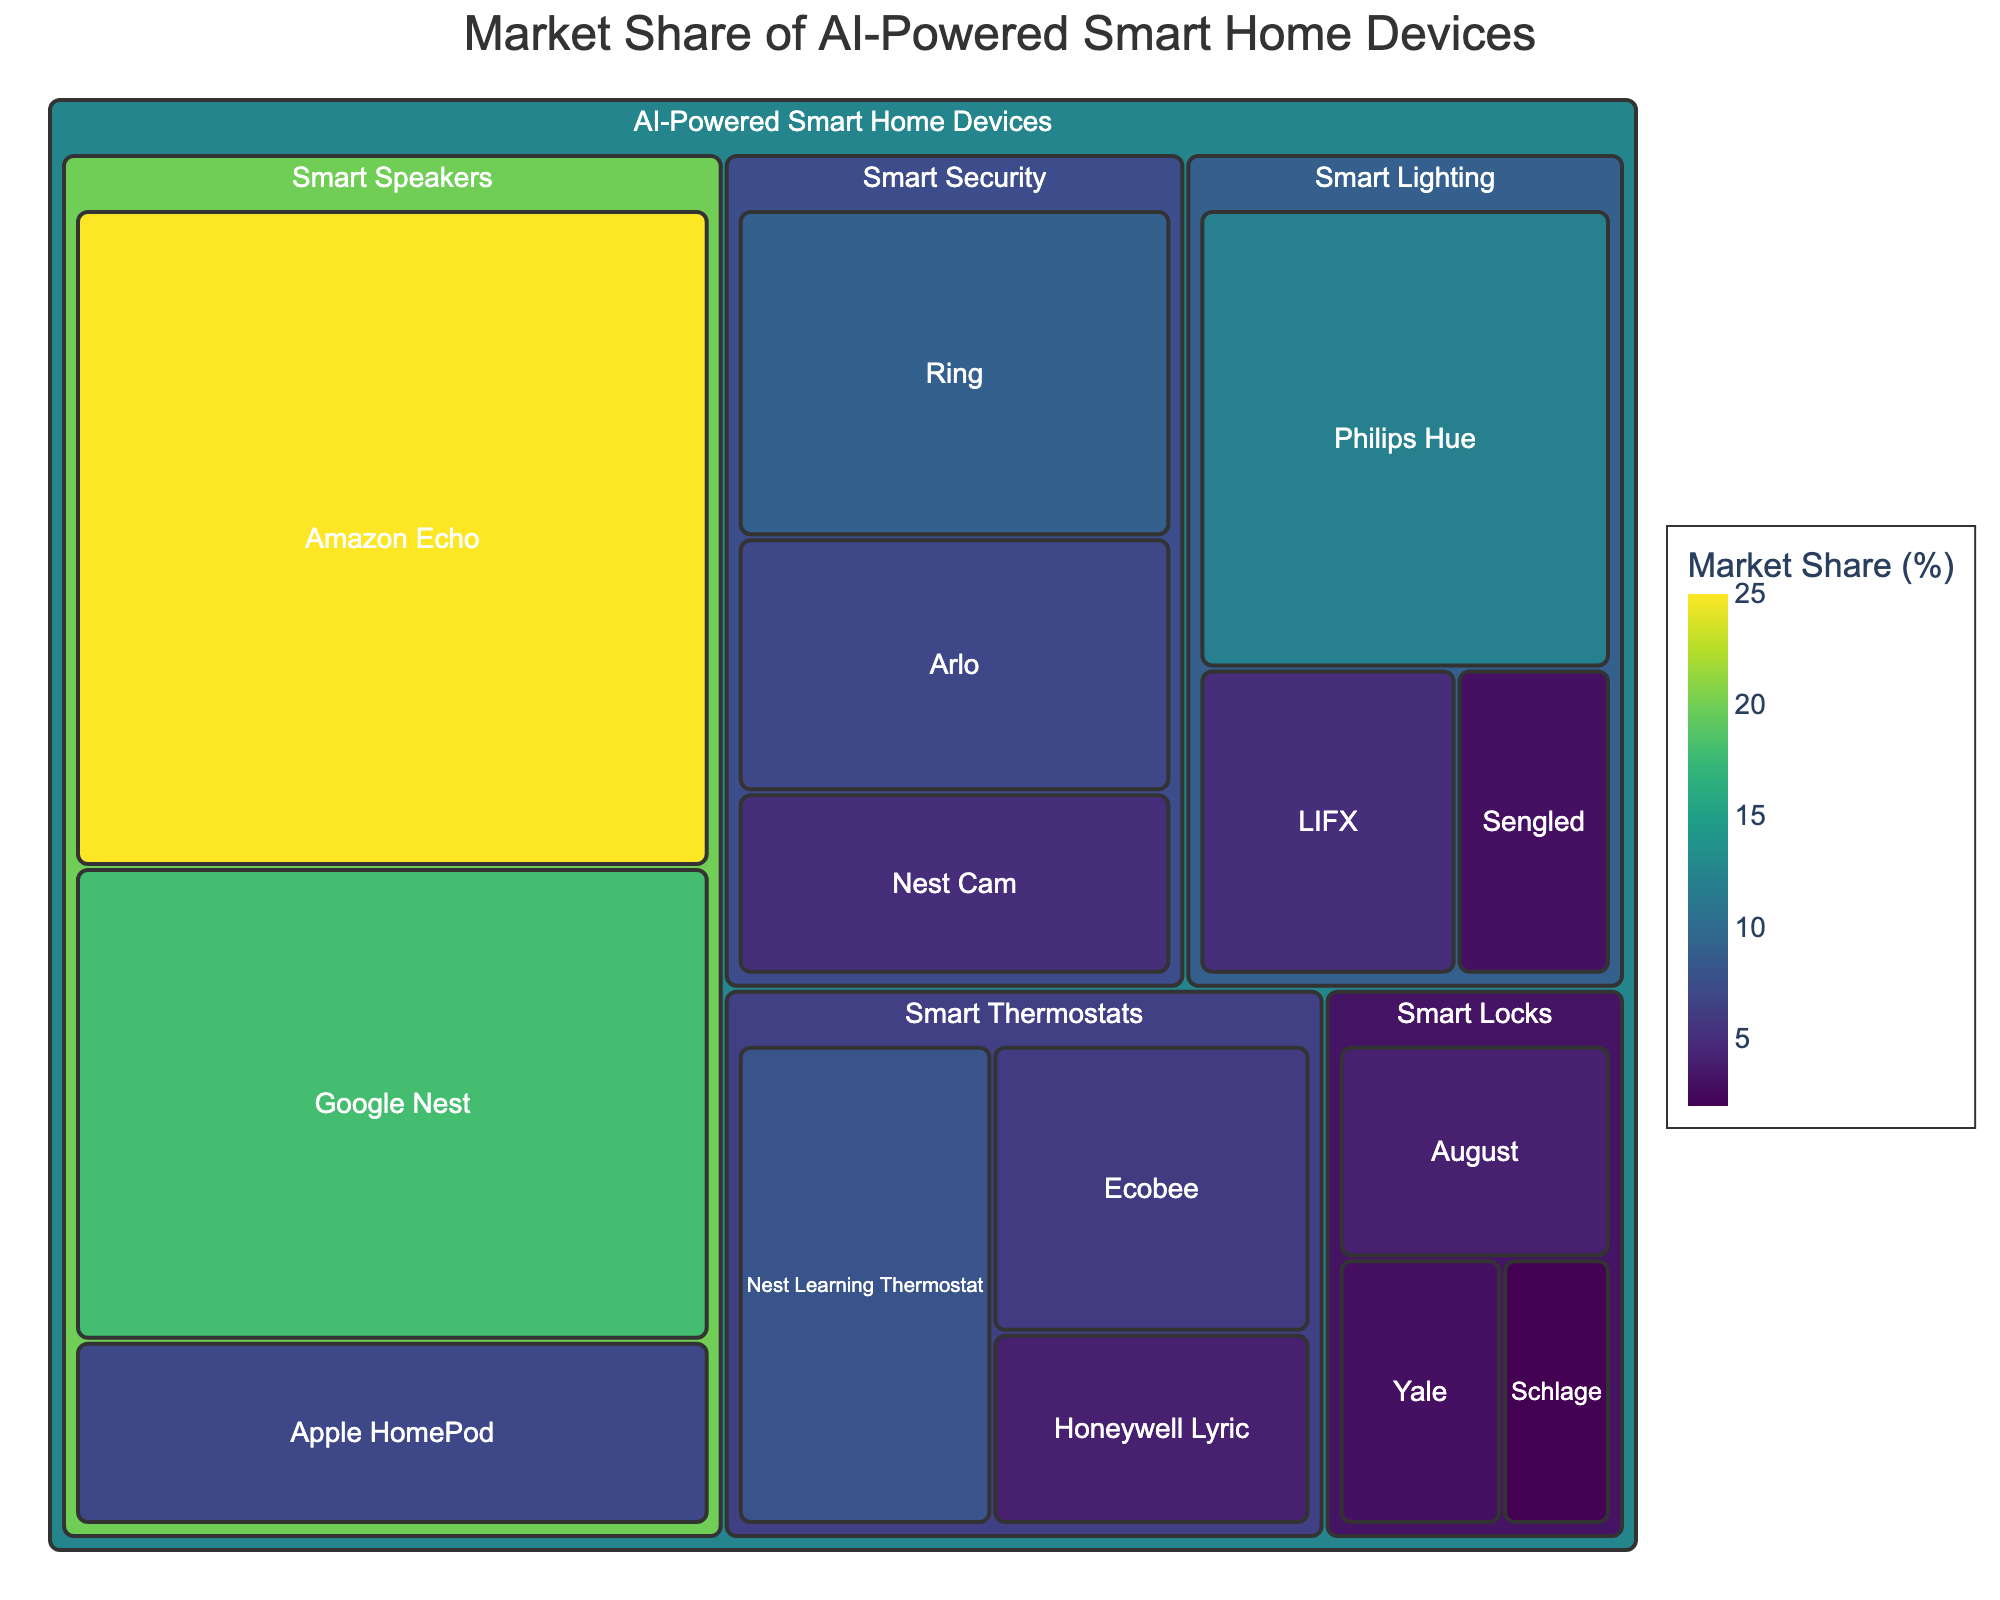What is the largest market share for a subcategory? The largest market share is represented by the largest block in the treemap, which is Amazon Echo with a market share of 25%.
Answer: 25% What category has the smallest overall market share percentage? To find the smallest category, sum the subcategory market shares and compare. The smallest category is Smart Locks with shares of 4%, 3%, and 2%, totaling 9%.
Answer: Smart Locks Which subcategory has the largest market share in the Smart Thermostats category? Within Smart Thermostats, compare the market shares of each subcategory. The highest is Nest Learning Thermostat with 8%.
Answer: Nest Learning Thermostat What is the average market share of the Smart Speakers subcategories? Add the market shares of Amazon Echo (25%), Google Nest (18%), and Apple HomePod (7%), then divide by 3. (25 + 18 + 7) / 3 = 16.67.
Answer: 16.67% How does the market share of Philips Hue compare to LIFX in the Smart Lighting category? Philips Hue has a market share of 12%, and LIFX has 5%. Philips Hue has a larger share.
Answer: Philips Hue has a larger market share of 12% compared to 5% How many categories have subcategories with market shares lower than 5%? Identify the subcategories with shares less than 5% and count their categories. There are Smart Lighting (Sengled), Smart Thermostats (Honeywell Lyric), and Smart Locks (Yale, Schlage).
Answer: 3 categories What is the combined market share of all the Smart Security subcategories? Sum the market shares of Ring (9%), Arlo (7%), and Nest Cam (5%). 9 + 7 + 5 = 21.
Answer: 21% Which category has the highest combined market share? Sum the market shares of each main category: Smart Speakers (25+18+7=50), Smart Lighting (12+5+3=20), Smart Thermostats (8+6+4=18), Smart Security (9+7+5=21), Smart Locks (4+3+2=9). Smart Speakers have the highest total.
Answer: Smart Speakers What is the difference in market share between Nest Cam and Google Nest? Subtract the market share of Nest Cam (5%) from Google Nest (18%). 18 - 5 = 13.
Answer: 13% Which subcategory in Smart Security has the smallest market share? Compare the market shares in Smart Security. The smallest is Nest Cam with 5%.
Answer: Nest Cam 